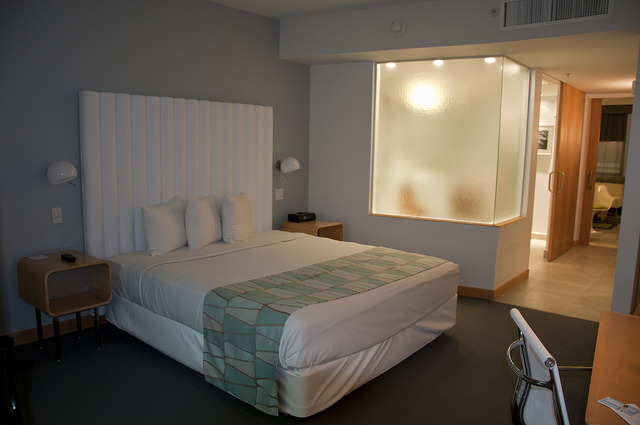How many doors in this closet? 1 